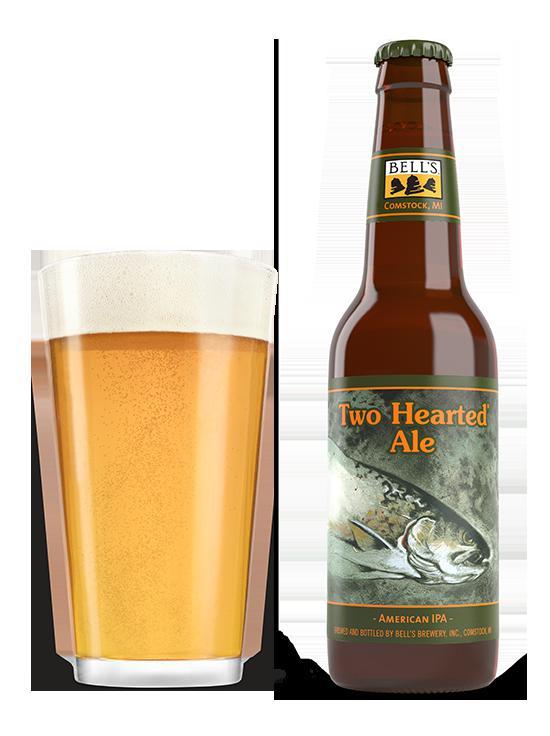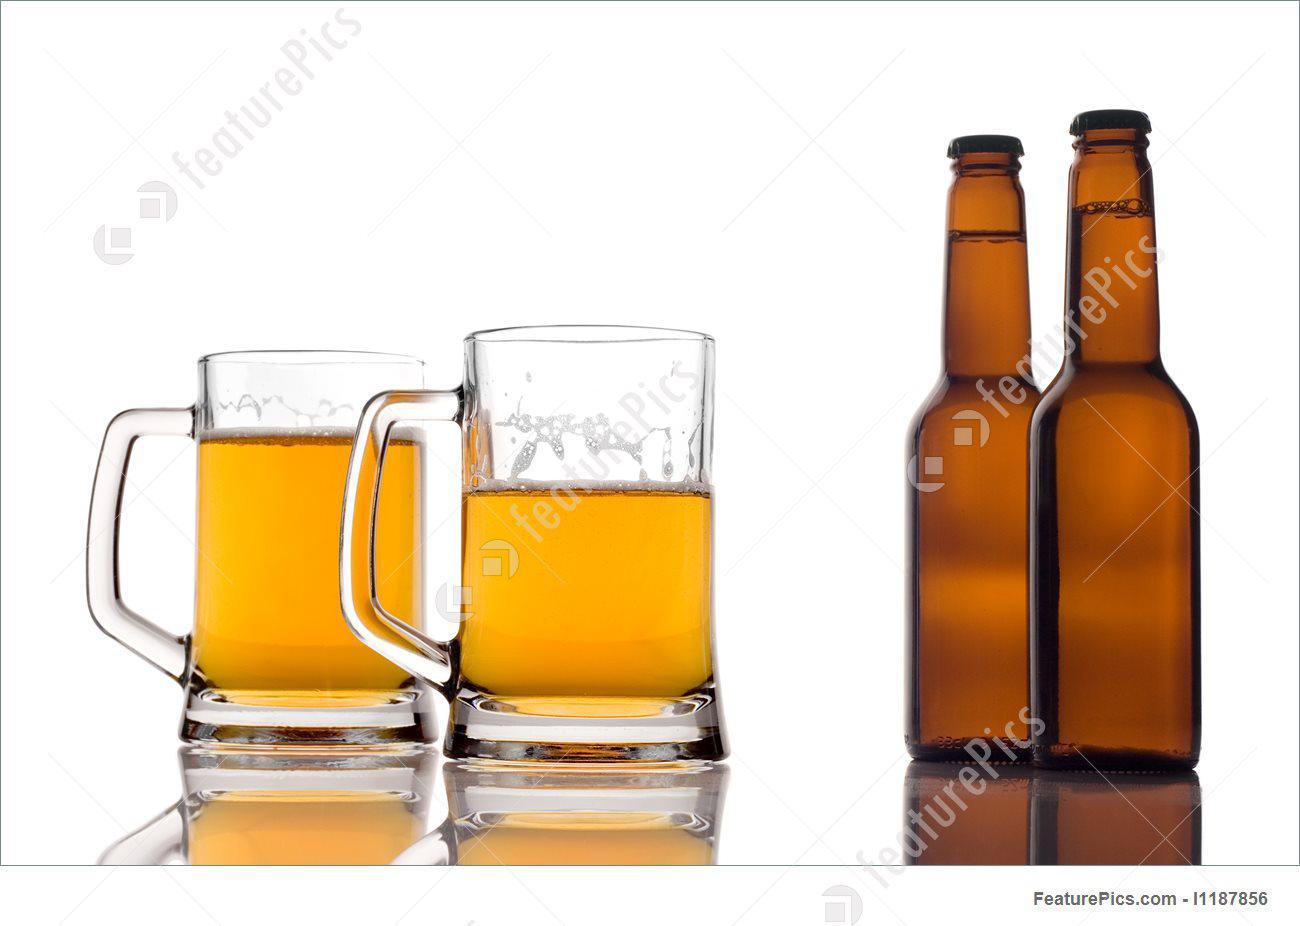The first image is the image on the left, the second image is the image on the right. Considering the images on both sides, is "In one image, at least two beer bottles are capped and ice, but do not have a label." valid? Answer yes or no. No. The first image is the image on the left, the second image is the image on the right. For the images shown, is this caption "Bottles are protruding from a pile of ice." true? Answer yes or no. No. 